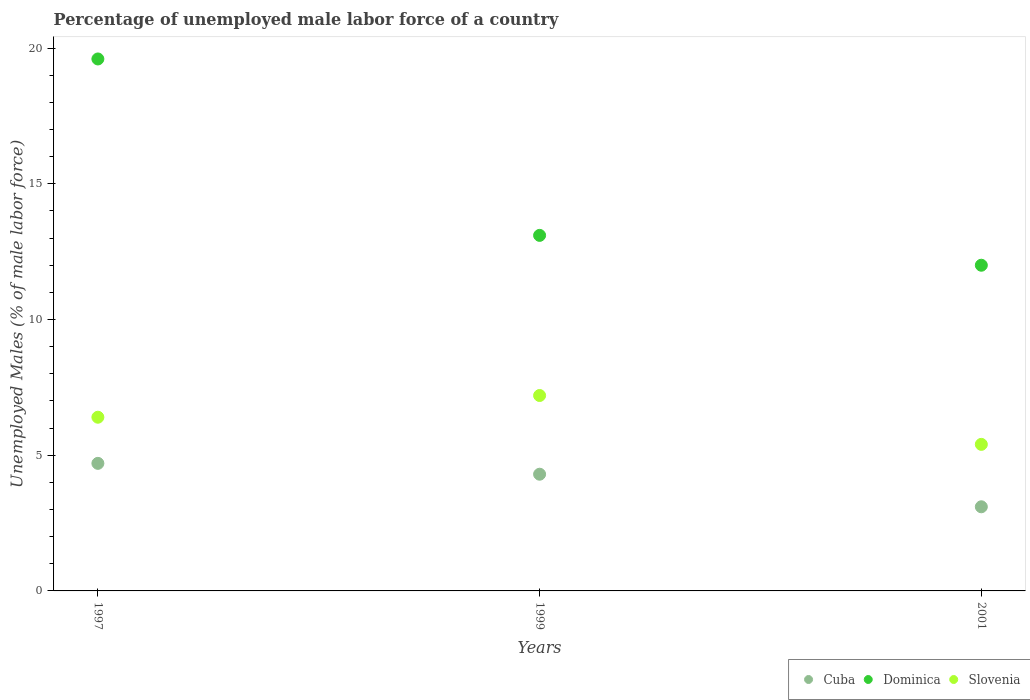What is the percentage of unemployed male labor force in Dominica in 2001?
Your answer should be very brief. 12. Across all years, what is the maximum percentage of unemployed male labor force in Dominica?
Keep it short and to the point. 19.6. Across all years, what is the minimum percentage of unemployed male labor force in Slovenia?
Give a very brief answer. 5.4. In which year was the percentage of unemployed male labor force in Slovenia maximum?
Your answer should be very brief. 1999. In which year was the percentage of unemployed male labor force in Cuba minimum?
Offer a very short reply. 2001. What is the total percentage of unemployed male labor force in Slovenia in the graph?
Keep it short and to the point. 19. What is the difference between the percentage of unemployed male labor force in Slovenia in 1997 and that in 1999?
Make the answer very short. -0.8. What is the difference between the percentage of unemployed male labor force in Cuba in 1997 and the percentage of unemployed male labor force in Dominica in 2001?
Your answer should be very brief. -7.3. What is the average percentage of unemployed male labor force in Slovenia per year?
Provide a short and direct response. 6.33. In the year 1999, what is the difference between the percentage of unemployed male labor force in Slovenia and percentage of unemployed male labor force in Dominica?
Keep it short and to the point. -5.9. What is the ratio of the percentage of unemployed male labor force in Cuba in 1997 to that in 2001?
Your response must be concise. 1.52. Is the percentage of unemployed male labor force in Dominica in 1997 less than that in 1999?
Make the answer very short. No. Is the difference between the percentage of unemployed male labor force in Slovenia in 1997 and 2001 greater than the difference between the percentage of unemployed male labor force in Dominica in 1997 and 2001?
Give a very brief answer. No. What is the difference between the highest and the second highest percentage of unemployed male labor force in Slovenia?
Your answer should be compact. 0.8. What is the difference between the highest and the lowest percentage of unemployed male labor force in Slovenia?
Offer a very short reply. 1.8. In how many years, is the percentage of unemployed male labor force in Dominica greater than the average percentage of unemployed male labor force in Dominica taken over all years?
Ensure brevity in your answer.  1. Is the percentage of unemployed male labor force in Dominica strictly greater than the percentage of unemployed male labor force in Cuba over the years?
Offer a terse response. Yes. Is the percentage of unemployed male labor force in Cuba strictly less than the percentage of unemployed male labor force in Slovenia over the years?
Give a very brief answer. Yes. What is the difference between two consecutive major ticks on the Y-axis?
Give a very brief answer. 5. Are the values on the major ticks of Y-axis written in scientific E-notation?
Offer a very short reply. No. Does the graph contain grids?
Your answer should be compact. No. Where does the legend appear in the graph?
Give a very brief answer. Bottom right. What is the title of the graph?
Your answer should be compact. Percentage of unemployed male labor force of a country. Does "Albania" appear as one of the legend labels in the graph?
Offer a very short reply. No. What is the label or title of the X-axis?
Provide a short and direct response. Years. What is the label or title of the Y-axis?
Make the answer very short. Unemployed Males (% of male labor force). What is the Unemployed Males (% of male labor force) of Cuba in 1997?
Give a very brief answer. 4.7. What is the Unemployed Males (% of male labor force) of Dominica in 1997?
Offer a terse response. 19.6. What is the Unemployed Males (% of male labor force) of Slovenia in 1997?
Give a very brief answer. 6.4. What is the Unemployed Males (% of male labor force) in Cuba in 1999?
Give a very brief answer. 4.3. What is the Unemployed Males (% of male labor force) in Dominica in 1999?
Make the answer very short. 13.1. What is the Unemployed Males (% of male labor force) of Slovenia in 1999?
Offer a terse response. 7.2. What is the Unemployed Males (% of male labor force) of Cuba in 2001?
Your answer should be compact. 3.1. What is the Unemployed Males (% of male labor force) in Dominica in 2001?
Keep it short and to the point. 12. What is the Unemployed Males (% of male labor force) in Slovenia in 2001?
Your response must be concise. 5.4. Across all years, what is the maximum Unemployed Males (% of male labor force) of Cuba?
Ensure brevity in your answer.  4.7. Across all years, what is the maximum Unemployed Males (% of male labor force) of Dominica?
Keep it short and to the point. 19.6. Across all years, what is the maximum Unemployed Males (% of male labor force) of Slovenia?
Offer a very short reply. 7.2. Across all years, what is the minimum Unemployed Males (% of male labor force) of Cuba?
Keep it short and to the point. 3.1. Across all years, what is the minimum Unemployed Males (% of male labor force) of Slovenia?
Your answer should be compact. 5.4. What is the total Unemployed Males (% of male labor force) of Dominica in the graph?
Provide a succinct answer. 44.7. What is the total Unemployed Males (% of male labor force) of Slovenia in the graph?
Keep it short and to the point. 19. What is the difference between the Unemployed Males (% of male labor force) in Dominica in 1997 and that in 1999?
Keep it short and to the point. 6.5. What is the difference between the Unemployed Males (% of male labor force) in Slovenia in 1997 and that in 2001?
Keep it short and to the point. 1. What is the difference between the Unemployed Males (% of male labor force) of Dominica in 1999 and that in 2001?
Your answer should be compact. 1.1. What is the difference between the Unemployed Males (% of male labor force) in Cuba in 1997 and the Unemployed Males (% of male labor force) in Dominica in 1999?
Make the answer very short. -8.4. What is the difference between the Unemployed Males (% of male labor force) of Cuba in 1997 and the Unemployed Males (% of male labor force) of Slovenia in 1999?
Offer a terse response. -2.5. What is the difference between the Unemployed Males (% of male labor force) of Dominica in 1997 and the Unemployed Males (% of male labor force) of Slovenia in 1999?
Provide a succinct answer. 12.4. What is the difference between the Unemployed Males (% of male labor force) of Dominica in 1997 and the Unemployed Males (% of male labor force) of Slovenia in 2001?
Give a very brief answer. 14.2. What is the average Unemployed Males (% of male labor force) in Cuba per year?
Provide a succinct answer. 4.03. What is the average Unemployed Males (% of male labor force) of Slovenia per year?
Provide a succinct answer. 6.33. In the year 1997, what is the difference between the Unemployed Males (% of male labor force) in Cuba and Unemployed Males (% of male labor force) in Dominica?
Provide a short and direct response. -14.9. In the year 1997, what is the difference between the Unemployed Males (% of male labor force) of Cuba and Unemployed Males (% of male labor force) of Slovenia?
Keep it short and to the point. -1.7. In the year 1997, what is the difference between the Unemployed Males (% of male labor force) of Dominica and Unemployed Males (% of male labor force) of Slovenia?
Your response must be concise. 13.2. In the year 1999, what is the difference between the Unemployed Males (% of male labor force) of Cuba and Unemployed Males (% of male labor force) of Slovenia?
Provide a short and direct response. -2.9. In the year 1999, what is the difference between the Unemployed Males (% of male labor force) in Dominica and Unemployed Males (% of male labor force) in Slovenia?
Your answer should be very brief. 5.9. In the year 2001, what is the difference between the Unemployed Males (% of male labor force) of Cuba and Unemployed Males (% of male labor force) of Slovenia?
Offer a very short reply. -2.3. In the year 2001, what is the difference between the Unemployed Males (% of male labor force) in Dominica and Unemployed Males (% of male labor force) in Slovenia?
Your response must be concise. 6.6. What is the ratio of the Unemployed Males (% of male labor force) of Cuba in 1997 to that in 1999?
Make the answer very short. 1.09. What is the ratio of the Unemployed Males (% of male labor force) in Dominica in 1997 to that in 1999?
Offer a very short reply. 1.5. What is the ratio of the Unemployed Males (% of male labor force) of Cuba in 1997 to that in 2001?
Make the answer very short. 1.52. What is the ratio of the Unemployed Males (% of male labor force) in Dominica in 1997 to that in 2001?
Make the answer very short. 1.63. What is the ratio of the Unemployed Males (% of male labor force) of Slovenia in 1997 to that in 2001?
Your response must be concise. 1.19. What is the ratio of the Unemployed Males (% of male labor force) of Cuba in 1999 to that in 2001?
Ensure brevity in your answer.  1.39. What is the ratio of the Unemployed Males (% of male labor force) of Dominica in 1999 to that in 2001?
Your response must be concise. 1.09. What is the difference between the highest and the second highest Unemployed Males (% of male labor force) in Slovenia?
Your response must be concise. 0.8. What is the difference between the highest and the lowest Unemployed Males (% of male labor force) in Cuba?
Your response must be concise. 1.6. 